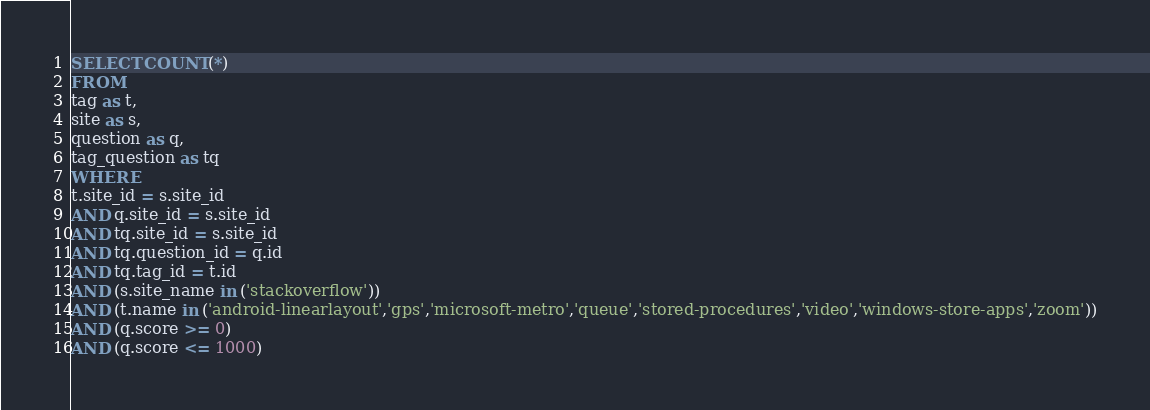<code> <loc_0><loc_0><loc_500><loc_500><_SQL_>SELECT COUNT(*)
FROM
tag as t,
site as s,
question as q,
tag_question as tq
WHERE
t.site_id = s.site_id
AND q.site_id = s.site_id
AND tq.site_id = s.site_id
AND tq.question_id = q.id
AND tq.tag_id = t.id
AND (s.site_name in ('stackoverflow'))
AND (t.name in ('android-linearlayout','gps','microsoft-metro','queue','stored-procedures','video','windows-store-apps','zoom'))
AND (q.score >= 0)
AND (q.score <= 1000)
</code> 